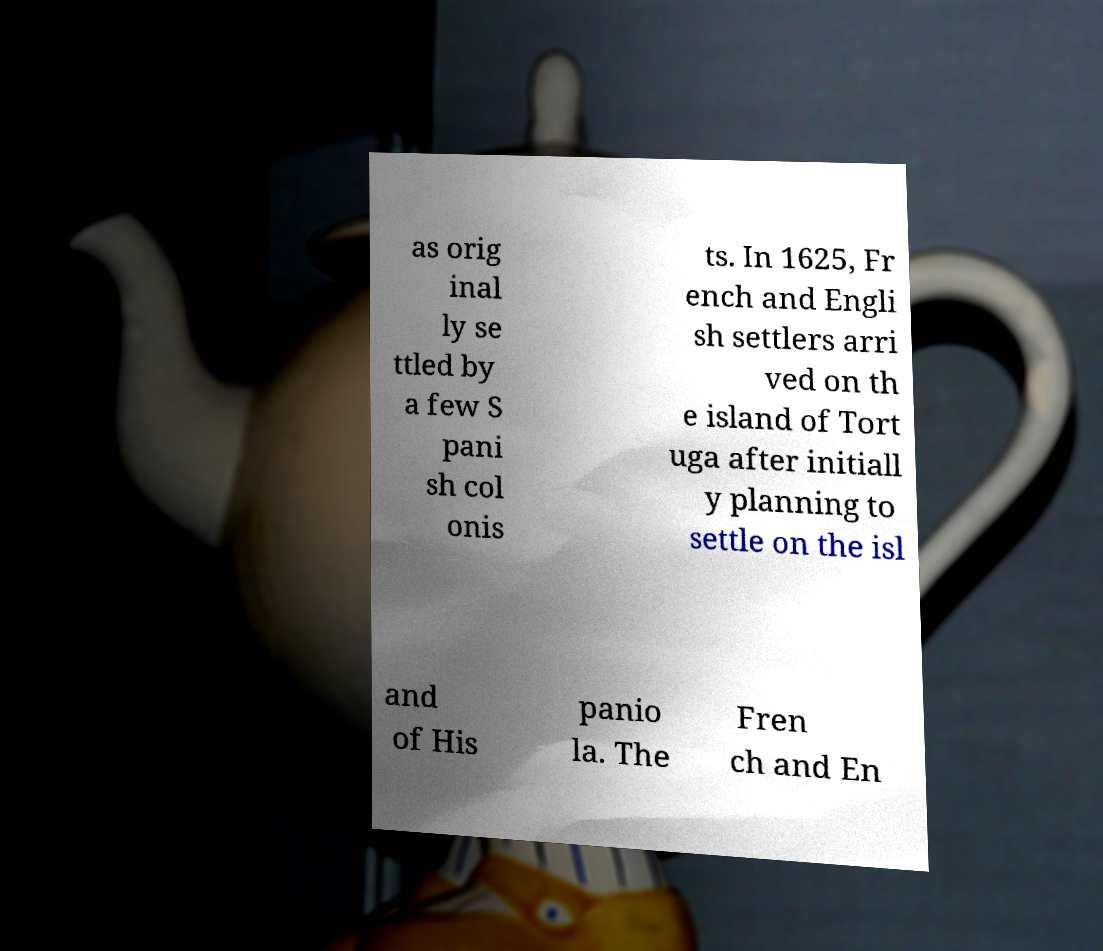For documentation purposes, I need the text within this image transcribed. Could you provide that? as orig inal ly se ttled by a few S pani sh col onis ts. In 1625, Fr ench and Engli sh settlers arri ved on th e island of Tort uga after initiall y planning to settle on the isl and of His panio la. The Fren ch and En 